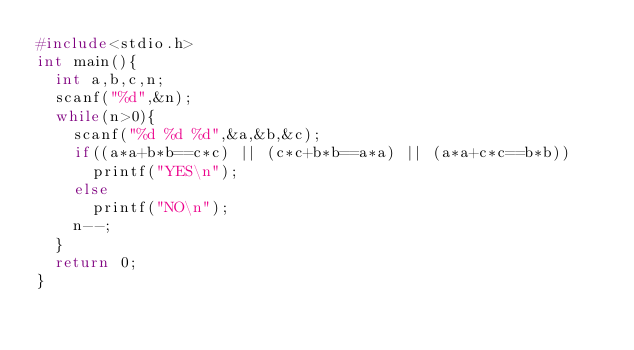Convert code to text. <code><loc_0><loc_0><loc_500><loc_500><_C_>#include<stdio.h>
int main(){
	int a,b,c,n;
	scanf("%d",&n);
	while(n>0){
		scanf("%d %d %d",&a,&b,&c);
		if((a*a+b*b==c*c) || (c*c+b*b==a*a) || (a*a+c*c==b*b))
			printf("YES\n");
		else
			printf("NO\n");
		n--;
	}
	return 0;
}
</code> 